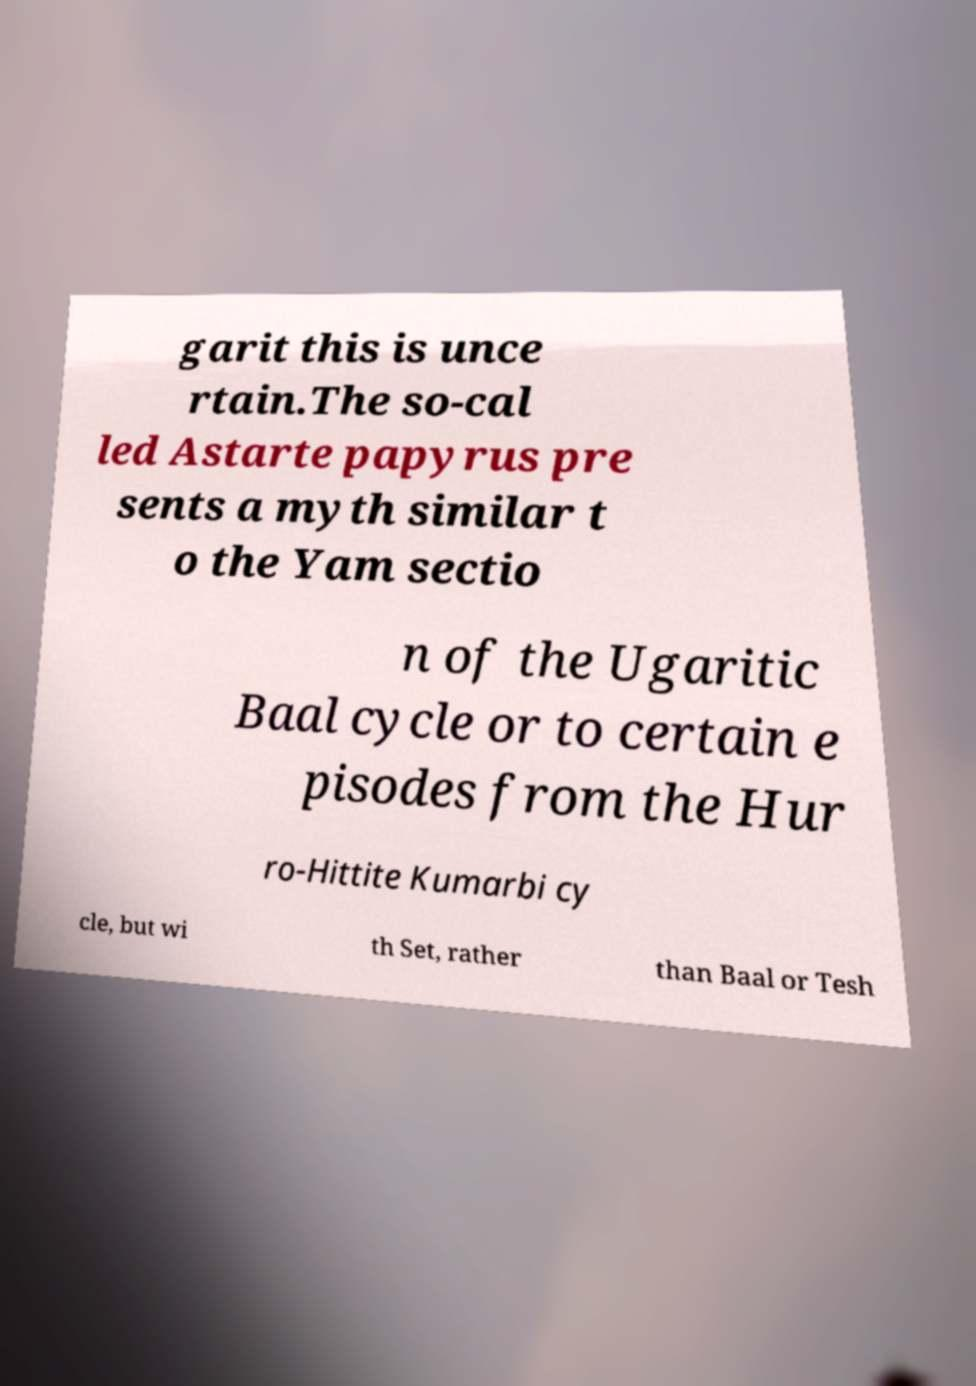I need the written content from this picture converted into text. Can you do that? garit this is unce rtain.The so-cal led Astarte papyrus pre sents a myth similar t o the Yam sectio n of the Ugaritic Baal cycle or to certain e pisodes from the Hur ro-Hittite Kumarbi cy cle, but wi th Set, rather than Baal or Tesh 